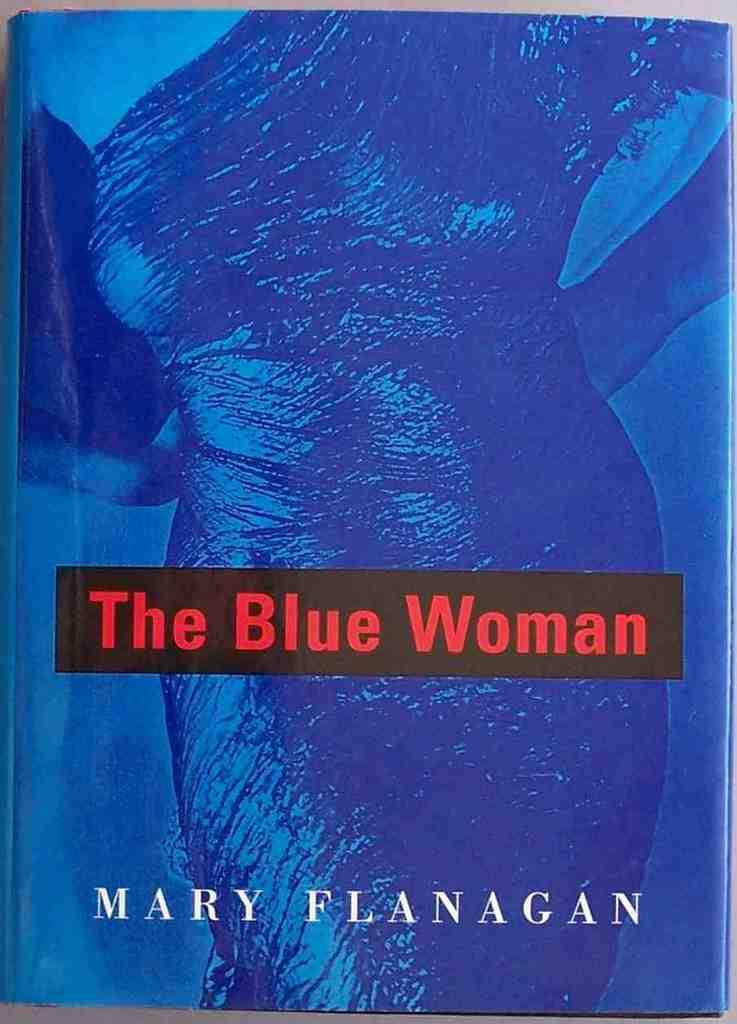<image>
Give a short and clear explanation of the subsequent image. A book titled The Blue Woman authored by Mary Flanagan 